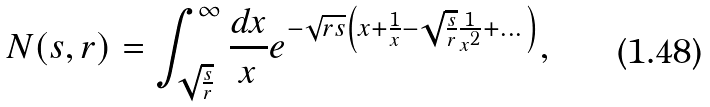<formula> <loc_0><loc_0><loc_500><loc_500>N ( s , r ) = \int _ { \sqrt { \frac { s } { r } } } ^ { \infty } \frac { d x } { x } e ^ { - \sqrt { r s } \left ( x + \frac { 1 } { x } - \sqrt { \frac { s } { r } } \frac { 1 } { x ^ { 2 } } + \dots \right ) } ,</formula> 